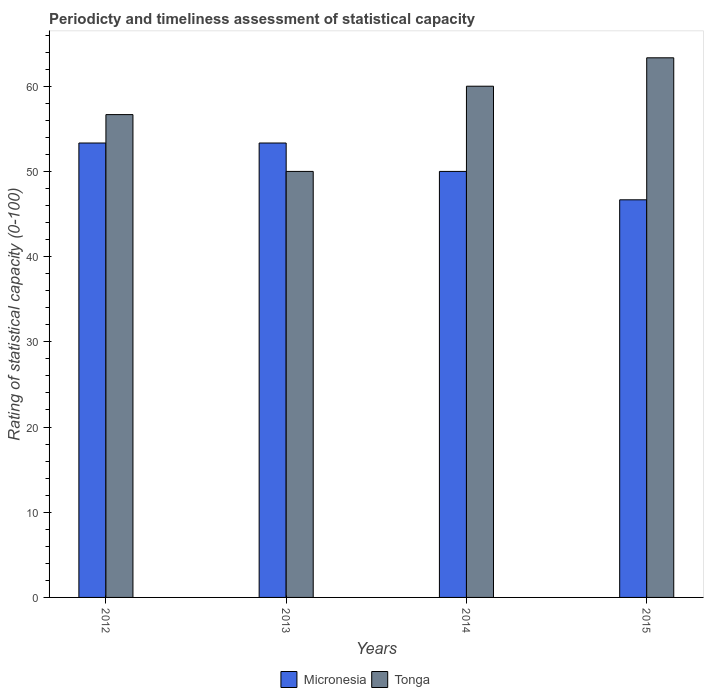How many groups of bars are there?
Your response must be concise. 4. Are the number of bars per tick equal to the number of legend labels?
Ensure brevity in your answer.  Yes. Are the number of bars on each tick of the X-axis equal?
Your response must be concise. Yes. How many bars are there on the 2nd tick from the left?
Ensure brevity in your answer.  2. How many bars are there on the 1st tick from the right?
Provide a short and direct response. 2. What is the label of the 3rd group of bars from the left?
Offer a very short reply. 2014. In how many cases, is the number of bars for a given year not equal to the number of legend labels?
Offer a terse response. 0. What is the rating of statistical capacity in Tonga in 2014?
Your response must be concise. 60. Across all years, what is the maximum rating of statistical capacity in Tonga?
Your answer should be very brief. 63.33. Across all years, what is the minimum rating of statistical capacity in Micronesia?
Your answer should be compact. 46.67. In which year was the rating of statistical capacity in Micronesia maximum?
Offer a very short reply. 2013. In which year was the rating of statistical capacity in Micronesia minimum?
Your response must be concise. 2015. What is the total rating of statistical capacity in Micronesia in the graph?
Your answer should be very brief. 203.33. What is the difference between the rating of statistical capacity in Micronesia in 2012 and that in 2014?
Your answer should be compact. 3.33. What is the difference between the rating of statistical capacity in Micronesia in 2014 and the rating of statistical capacity in Tonga in 2012?
Give a very brief answer. -6.67. What is the average rating of statistical capacity in Micronesia per year?
Offer a very short reply. 50.83. In the year 2012, what is the difference between the rating of statistical capacity in Tonga and rating of statistical capacity in Micronesia?
Your answer should be very brief. 3.33. What is the ratio of the rating of statistical capacity in Tonga in 2012 to that in 2014?
Offer a terse response. 0.94. Is the difference between the rating of statistical capacity in Tonga in 2014 and 2015 greater than the difference between the rating of statistical capacity in Micronesia in 2014 and 2015?
Offer a very short reply. No. What is the difference between the highest and the second highest rating of statistical capacity in Tonga?
Offer a terse response. 3.33. What is the difference between the highest and the lowest rating of statistical capacity in Tonga?
Provide a succinct answer. 13.33. Is the sum of the rating of statistical capacity in Tonga in 2012 and 2013 greater than the maximum rating of statistical capacity in Micronesia across all years?
Offer a very short reply. Yes. What does the 2nd bar from the left in 2012 represents?
Keep it short and to the point. Tonga. What does the 2nd bar from the right in 2014 represents?
Make the answer very short. Micronesia. How many bars are there?
Keep it short and to the point. 8. Are all the bars in the graph horizontal?
Your answer should be compact. No. How many years are there in the graph?
Give a very brief answer. 4. What is the difference between two consecutive major ticks on the Y-axis?
Make the answer very short. 10. Are the values on the major ticks of Y-axis written in scientific E-notation?
Your response must be concise. No. How many legend labels are there?
Keep it short and to the point. 2. How are the legend labels stacked?
Offer a terse response. Horizontal. What is the title of the graph?
Keep it short and to the point. Periodicty and timeliness assessment of statistical capacity. Does "Nicaragua" appear as one of the legend labels in the graph?
Provide a short and direct response. No. What is the label or title of the X-axis?
Make the answer very short. Years. What is the label or title of the Y-axis?
Your response must be concise. Rating of statistical capacity (0-100). What is the Rating of statistical capacity (0-100) of Micronesia in 2012?
Provide a short and direct response. 53.33. What is the Rating of statistical capacity (0-100) in Tonga in 2012?
Your response must be concise. 56.67. What is the Rating of statistical capacity (0-100) of Micronesia in 2013?
Offer a very short reply. 53.33. What is the Rating of statistical capacity (0-100) of Tonga in 2013?
Your response must be concise. 50. What is the Rating of statistical capacity (0-100) in Tonga in 2014?
Keep it short and to the point. 60. What is the Rating of statistical capacity (0-100) of Micronesia in 2015?
Give a very brief answer. 46.67. What is the Rating of statistical capacity (0-100) of Tonga in 2015?
Make the answer very short. 63.33. Across all years, what is the maximum Rating of statistical capacity (0-100) in Micronesia?
Ensure brevity in your answer.  53.33. Across all years, what is the maximum Rating of statistical capacity (0-100) of Tonga?
Your answer should be compact. 63.33. Across all years, what is the minimum Rating of statistical capacity (0-100) of Micronesia?
Keep it short and to the point. 46.67. What is the total Rating of statistical capacity (0-100) of Micronesia in the graph?
Ensure brevity in your answer.  203.33. What is the total Rating of statistical capacity (0-100) in Tonga in the graph?
Offer a terse response. 230. What is the difference between the Rating of statistical capacity (0-100) of Micronesia in 2012 and that in 2013?
Provide a short and direct response. -0. What is the difference between the Rating of statistical capacity (0-100) of Micronesia in 2012 and that in 2014?
Offer a very short reply. 3.33. What is the difference between the Rating of statistical capacity (0-100) of Tonga in 2012 and that in 2014?
Your answer should be compact. -3.33. What is the difference between the Rating of statistical capacity (0-100) in Micronesia in 2012 and that in 2015?
Provide a succinct answer. 6.67. What is the difference between the Rating of statistical capacity (0-100) in Tonga in 2012 and that in 2015?
Give a very brief answer. -6.67. What is the difference between the Rating of statistical capacity (0-100) in Micronesia in 2013 and that in 2015?
Your answer should be very brief. 6.67. What is the difference between the Rating of statistical capacity (0-100) in Tonga in 2013 and that in 2015?
Provide a short and direct response. -13.33. What is the difference between the Rating of statistical capacity (0-100) of Tonga in 2014 and that in 2015?
Provide a succinct answer. -3.33. What is the difference between the Rating of statistical capacity (0-100) in Micronesia in 2012 and the Rating of statistical capacity (0-100) in Tonga in 2013?
Provide a short and direct response. 3.33. What is the difference between the Rating of statistical capacity (0-100) of Micronesia in 2012 and the Rating of statistical capacity (0-100) of Tonga in 2014?
Your answer should be compact. -6.67. What is the difference between the Rating of statistical capacity (0-100) of Micronesia in 2012 and the Rating of statistical capacity (0-100) of Tonga in 2015?
Your answer should be compact. -10. What is the difference between the Rating of statistical capacity (0-100) of Micronesia in 2013 and the Rating of statistical capacity (0-100) of Tonga in 2014?
Ensure brevity in your answer.  -6.67. What is the difference between the Rating of statistical capacity (0-100) of Micronesia in 2013 and the Rating of statistical capacity (0-100) of Tonga in 2015?
Ensure brevity in your answer.  -10. What is the difference between the Rating of statistical capacity (0-100) in Micronesia in 2014 and the Rating of statistical capacity (0-100) in Tonga in 2015?
Provide a short and direct response. -13.33. What is the average Rating of statistical capacity (0-100) of Micronesia per year?
Give a very brief answer. 50.83. What is the average Rating of statistical capacity (0-100) in Tonga per year?
Your answer should be very brief. 57.5. In the year 2013, what is the difference between the Rating of statistical capacity (0-100) of Micronesia and Rating of statistical capacity (0-100) of Tonga?
Your response must be concise. 3.33. In the year 2014, what is the difference between the Rating of statistical capacity (0-100) in Micronesia and Rating of statistical capacity (0-100) in Tonga?
Offer a terse response. -10. In the year 2015, what is the difference between the Rating of statistical capacity (0-100) in Micronesia and Rating of statistical capacity (0-100) in Tonga?
Offer a terse response. -16.67. What is the ratio of the Rating of statistical capacity (0-100) of Tonga in 2012 to that in 2013?
Offer a very short reply. 1.13. What is the ratio of the Rating of statistical capacity (0-100) in Micronesia in 2012 to that in 2014?
Provide a succinct answer. 1.07. What is the ratio of the Rating of statistical capacity (0-100) of Micronesia in 2012 to that in 2015?
Give a very brief answer. 1.14. What is the ratio of the Rating of statistical capacity (0-100) in Tonga in 2012 to that in 2015?
Provide a short and direct response. 0.89. What is the ratio of the Rating of statistical capacity (0-100) in Micronesia in 2013 to that in 2014?
Offer a very short reply. 1.07. What is the ratio of the Rating of statistical capacity (0-100) in Tonga in 2013 to that in 2015?
Ensure brevity in your answer.  0.79. What is the ratio of the Rating of statistical capacity (0-100) of Micronesia in 2014 to that in 2015?
Your answer should be compact. 1.07. What is the ratio of the Rating of statistical capacity (0-100) in Tonga in 2014 to that in 2015?
Your answer should be very brief. 0.95. What is the difference between the highest and the second highest Rating of statistical capacity (0-100) of Tonga?
Offer a very short reply. 3.33. What is the difference between the highest and the lowest Rating of statistical capacity (0-100) in Micronesia?
Provide a succinct answer. 6.67. What is the difference between the highest and the lowest Rating of statistical capacity (0-100) in Tonga?
Give a very brief answer. 13.33. 